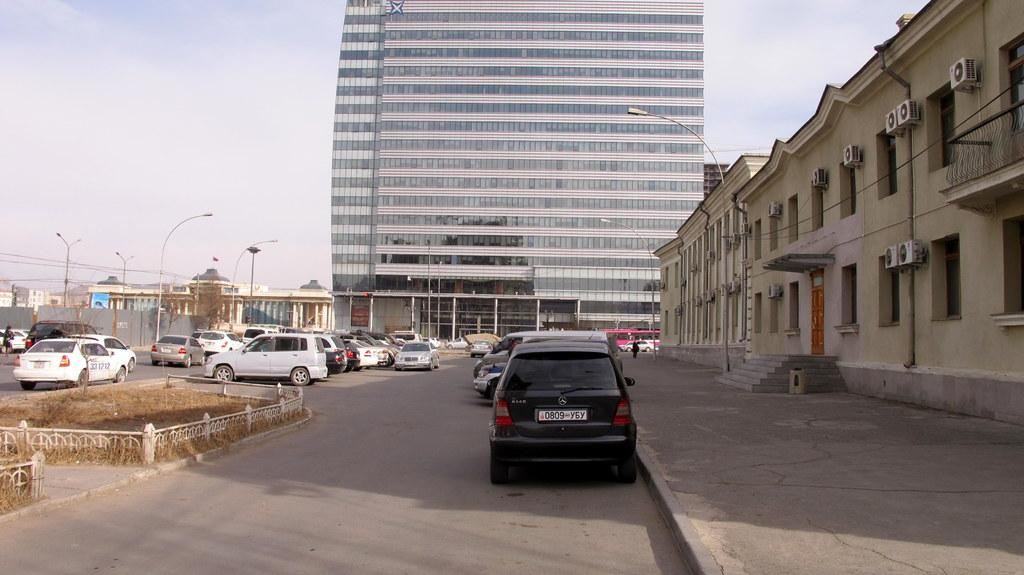What can be seen on the road in the image? There are vehicles on the road in the image. What type of vegetation is visible in the image? Dried grass is visible in the image. What structures are present in the image? There are buildings in the image. What is used to illuminate the area in the image? Lights are present on poles in the image. What is visible in the background of the image? The sky is visible in the background of the image. How many chairs are present in the image? There are no chairs visible in the image. What type of debt is being discussed in the image? There is no discussion of debt in the image; it features vehicles, dried grass, buildings, lights, and the sky. 